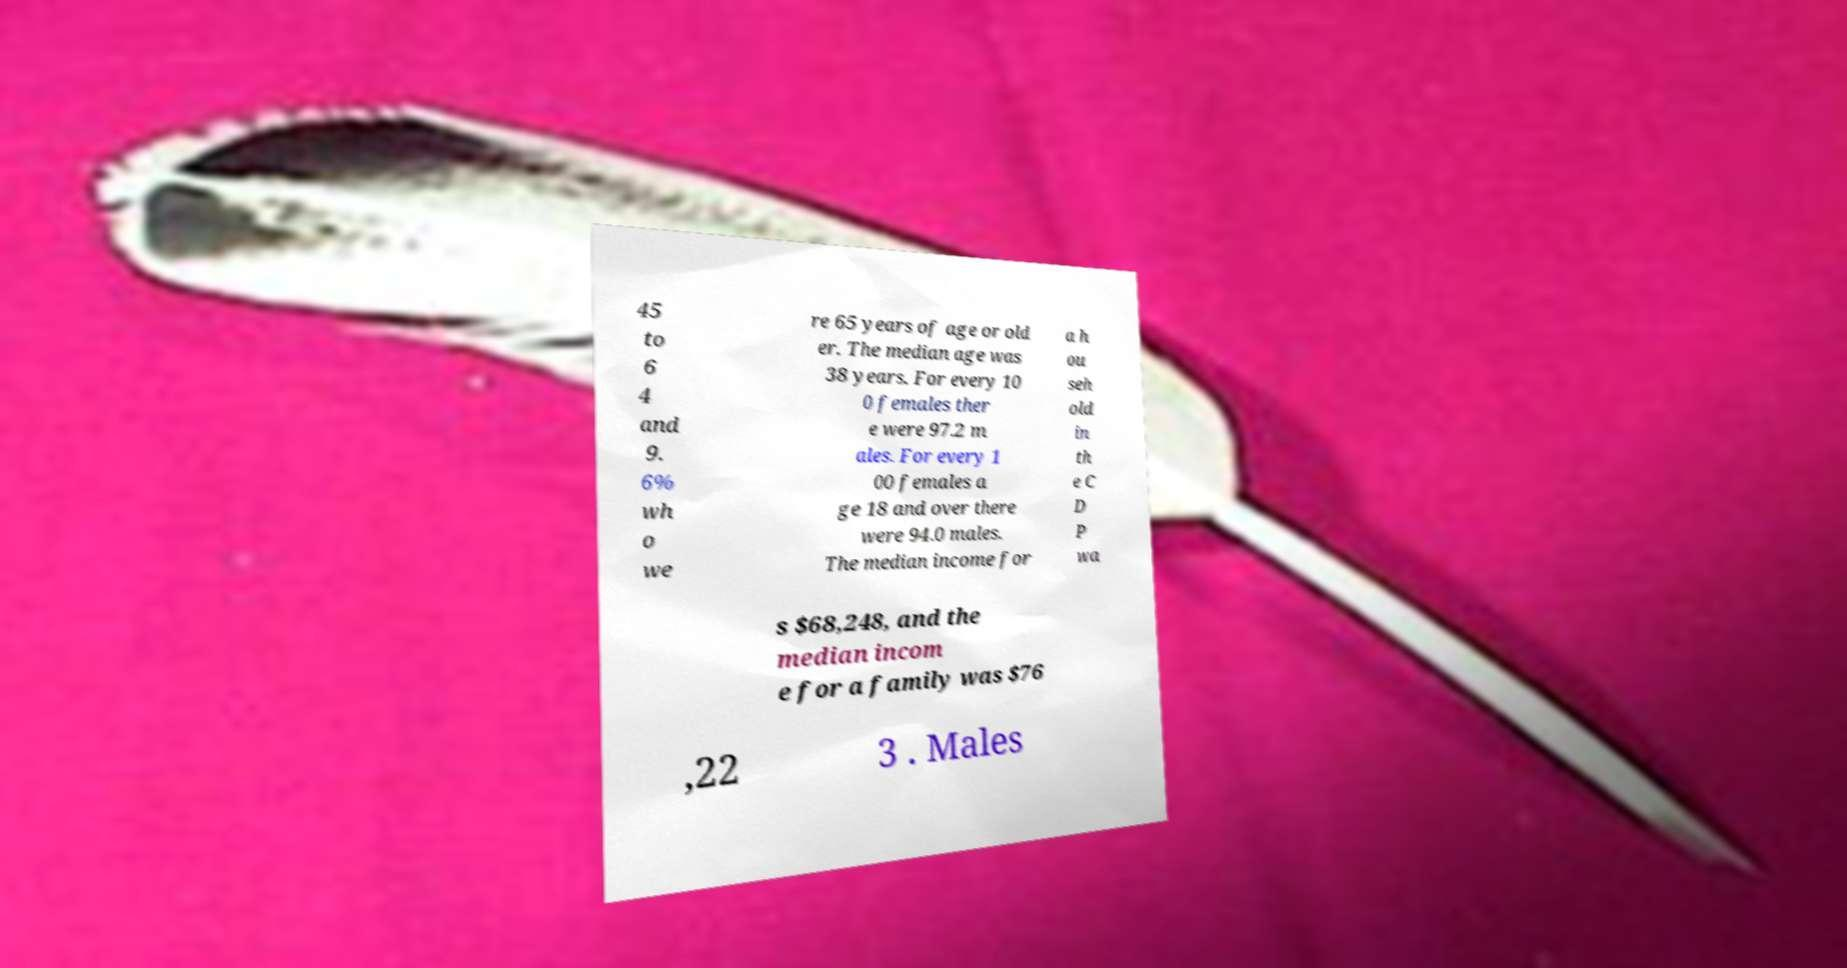Can you accurately transcribe the text from the provided image for me? 45 to 6 4 and 9. 6% wh o we re 65 years of age or old er. The median age was 38 years. For every 10 0 females ther e were 97.2 m ales. For every 1 00 females a ge 18 and over there were 94.0 males. The median income for a h ou seh old in th e C D P wa s $68,248, and the median incom e for a family was $76 ,22 3 . Males 